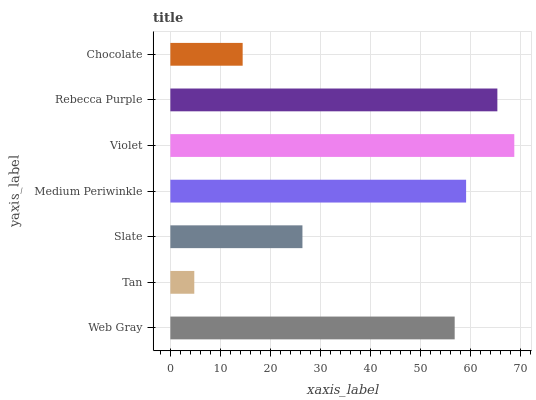Is Tan the minimum?
Answer yes or no. Yes. Is Violet the maximum?
Answer yes or no. Yes. Is Slate the minimum?
Answer yes or no. No. Is Slate the maximum?
Answer yes or no. No. Is Slate greater than Tan?
Answer yes or no. Yes. Is Tan less than Slate?
Answer yes or no. Yes. Is Tan greater than Slate?
Answer yes or no. No. Is Slate less than Tan?
Answer yes or no. No. Is Web Gray the high median?
Answer yes or no. Yes. Is Web Gray the low median?
Answer yes or no. Yes. Is Rebecca Purple the high median?
Answer yes or no. No. Is Tan the low median?
Answer yes or no. No. 